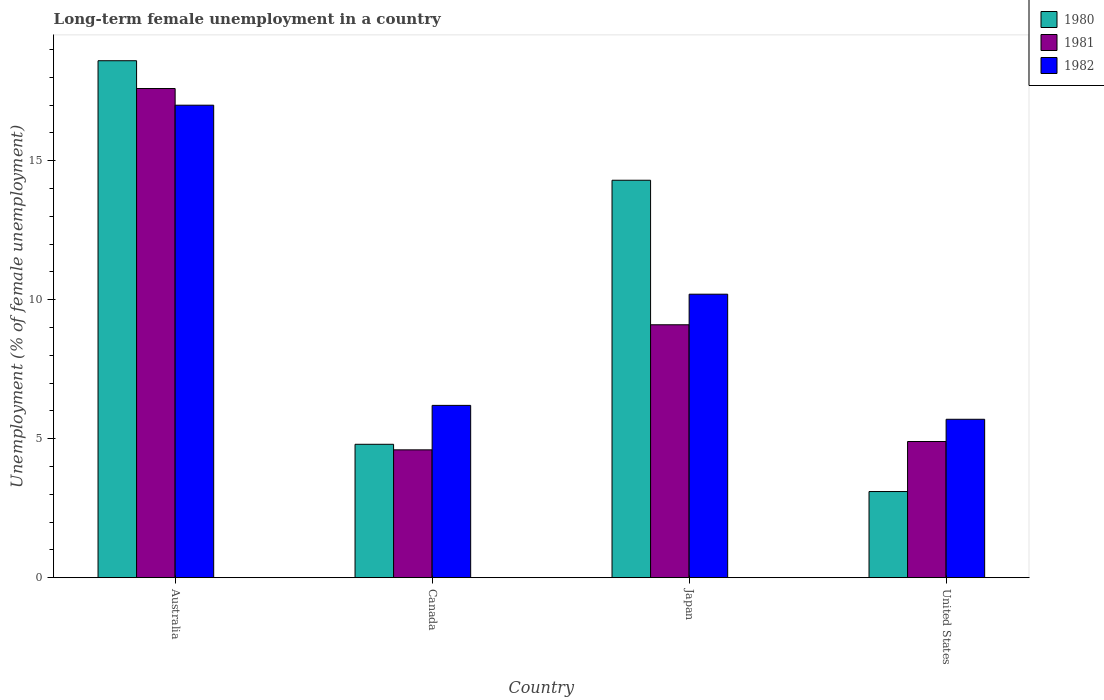Are the number of bars on each tick of the X-axis equal?
Give a very brief answer. Yes. What is the label of the 2nd group of bars from the left?
Your answer should be compact. Canada. What is the percentage of long-term unemployed female population in 1982 in Japan?
Your answer should be compact. 10.2. Across all countries, what is the maximum percentage of long-term unemployed female population in 1981?
Keep it short and to the point. 17.6. Across all countries, what is the minimum percentage of long-term unemployed female population in 1980?
Keep it short and to the point. 3.1. In which country was the percentage of long-term unemployed female population in 1981 minimum?
Keep it short and to the point. Canada. What is the total percentage of long-term unemployed female population in 1982 in the graph?
Your answer should be very brief. 39.1. What is the difference between the percentage of long-term unemployed female population in 1981 in Canada and that in United States?
Provide a short and direct response. -0.3. What is the difference between the percentage of long-term unemployed female population in 1982 in Canada and the percentage of long-term unemployed female population in 1980 in Australia?
Make the answer very short. -12.4. What is the average percentage of long-term unemployed female population in 1982 per country?
Keep it short and to the point. 9.77. What is the difference between the percentage of long-term unemployed female population of/in 1980 and percentage of long-term unemployed female population of/in 1982 in Japan?
Provide a short and direct response. 4.1. In how many countries, is the percentage of long-term unemployed female population in 1980 greater than 5 %?
Keep it short and to the point. 2. What is the ratio of the percentage of long-term unemployed female population in 1980 in Australia to that in Canada?
Your answer should be compact. 3.87. Is the difference between the percentage of long-term unemployed female population in 1980 in Canada and Japan greater than the difference between the percentage of long-term unemployed female population in 1982 in Canada and Japan?
Keep it short and to the point. No. What is the difference between the highest and the second highest percentage of long-term unemployed female population in 1982?
Your response must be concise. 6.8. What is the difference between the highest and the lowest percentage of long-term unemployed female population in 1980?
Your response must be concise. 15.5. In how many countries, is the percentage of long-term unemployed female population in 1981 greater than the average percentage of long-term unemployed female population in 1981 taken over all countries?
Keep it short and to the point. 2. What does the 1st bar from the right in Japan represents?
Give a very brief answer. 1982. How many bars are there?
Your response must be concise. 12. Are all the bars in the graph horizontal?
Provide a succinct answer. No. How many countries are there in the graph?
Give a very brief answer. 4. Are the values on the major ticks of Y-axis written in scientific E-notation?
Provide a succinct answer. No. Does the graph contain grids?
Your response must be concise. No. How many legend labels are there?
Your answer should be very brief. 3. How are the legend labels stacked?
Provide a succinct answer. Vertical. What is the title of the graph?
Give a very brief answer. Long-term female unemployment in a country. Does "1990" appear as one of the legend labels in the graph?
Ensure brevity in your answer.  No. What is the label or title of the X-axis?
Provide a short and direct response. Country. What is the label or title of the Y-axis?
Keep it short and to the point. Unemployment (% of female unemployment). What is the Unemployment (% of female unemployment) in 1980 in Australia?
Offer a terse response. 18.6. What is the Unemployment (% of female unemployment) of 1981 in Australia?
Your answer should be compact. 17.6. What is the Unemployment (% of female unemployment) in 1982 in Australia?
Provide a succinct answer. 17. What is the Unemployment (% of female unemployment) in 1980 in Canada?
Give a very brief answer. 4.8. What is the Unemployment (% of female unemployment) in 1981 in Canada?
Provide a succinct answer. 4.6. What is the Unemployment (% of female unemployment) in 1982 in Canada?
Offer a very short reply. 6.2. What is the Unemployment (% of female unemployment) in 1980 in Japan?
Make the answer very short. 14.3. What is the Unemployment (% of female unemployment) of 1981 in Japan?
Your response must be concise. 9.1. What is the Unemployment (% of female unemployment) in 1982 in Japan?
Offer a very short reply. 10.2. What is the Unemployment (% of female unemployment) in 1980 in United States?
Provide a succinct answer. 3.1. What is the Unemployment (% of female unemployment) in 1981 in United States?
Ensure brevity in your answer.  4.9. What is the Unemployment (% of female unemployment) in 1982 in United States?
Keep it short and to the point. 5.7. Across all countries, what is the maximum Unemployment (% of female unemployment) of 1980?
Offer a terse response. 18.6. Across all countries, what is the maximum Unemployment (% of female unemployment) of 1981?
Provide a succinct answer. 17.6. Across all countries, what is the minimum Unemployment (% of female unemployment) of 1980?
Ensure brevity in your answer.  3.1. Across all countries, what is the minimum Unemployment (% of female unemployment) of 1981?
Your response must be concise. 4.6. Across all countries, what is the minimum Unemployment (% of female unemployment) in 1982?
Your answer should be very brief. 5.7. What is the total Unemployment (% of female unemployment) in 1980 in the graph?
Your response must be concise. 40.8. What is the total Unemployment (% of female unemployment) of 1981 in the graph?
Provide a succinct answer. 36.2. What is the total Unemployment (% of female unemployment) in 1982 in the graph?
Ensure brevity in your answer.  39.1. What is the difference between the Unemployment (% of female unemployment) in 1982 in Australia and that in Canada?
Keep it short and to the point. 10.8. What is the difference between the Unemployment (% of female unemployment) of 1980 in Australia and that in Japan?
Your answer should be very brief. 4.3. What is the difference between the Unemployment (% of female unemployment) of 1980 in Australia and that in United States?
Your answer should be compact. 15.5. What is the difference between the Unemployment (% of female unemployment) in 1981 in Australia and that in United States?
Offer a terse response. 12.7. What is the difference between the Unemployment (% of female unemployment) in 1982 in Australia and that in United States?
Make the answer very short. 11.3. What is the difference between the Unemployment (% of female unemployment) of 1980 in Canada and that in Japan?
Your response must be concise. -9.5. What is the difference between the Unemployment (% of female unemployment) of 1982 in Canada and that in Japan?
Give a very brief answer. -4. What is the difference between the Unemployment (% of female unemployment) of 1980 in Canada and that in United States?
Keep it short and to the point. 1.7. What is the difference between the Unemployment (% of female unemployment) in 1982 in Canada and that in United States?
Keep it short and to the point. 0.5. What is the difference between the Unemployment (% of female unemployment) in 1980 in Japan and that in United States?
Keep it short and to the point. 11.2. What is the difference between the Unemployment (% of female unemployment) of 1981 in Japan and that in United States?
Your response must be concise. 4.2. What is the difference between the Unemployment (% of female unemployment) in 1980 in Australia and the Unemployment (% of female unemployment) in 1981 in Canada?
Give a very brief answer. 14. What is the difference between the Unemployment (% of female unemployment) in 1980 in Australia and the Unemployment (% of female unemployment) in 1981 in Japan?
Make the answer very short. 9.5. What is the difference between the Unemployment (% of female unemployment) in 1980 in Australia and the Unemployment (% of female unemployment) in 1982 in Japan?
Your response must be concise. 8.4. What is the difference between the Unemployment (% of female unemployment) in 1981 in Australia and the Unemployment (% of female unemployment) in 1982 in Japan?
Offer a very short reply. 7.4. What is the difference between the Unemployment (% of female unemployment) in 1981 in Australia and the Unemployment (% of female unemployment) in 1982 in United States?
Make the answer very short. 11.9. What is the difference between the Unemployment (% of female unemployment) in 1980 in Canada and the Unemployment (% of female unemployment) in 1982 in Japan?
Your answer should be very brief. -5.4. What is the difference between the Unemployment (% of female unemployment) of 1980 in Canada and the Unemployment (% of female unemployment) of 1981 in United States?
Give a very brief answer. -0.1. What is the difference between the Unemployment (% of female unemployment) in 1980 in Canada and the Unemployment (% of female unemployment) in 1982 in United States?
Keep it short and to the point. -0.9. What is the difference between the Unemployment (% of female unemployment) of 1980 in Japan and the Unemployment (% of female unemployment) of 1982 in United States?
Provide a short and direct response. 8.6. What is the difference between the Unemployment (% of female unemployment) of 1981 in Japan and the Unemployment (% of female unemployment) of 1982 in United States?
Your answer should be very brief. 3.4. What is the average Unemployment (% of female unemployment) in 1981 per country?
Offer a terse response. 9.05. What is the average Unemployment (% of female unemployment) of 1982 per country?
Give a very brief answer. 9.78. What is the difference between the Unemployment (% of female unemployment) in 1980 and Unemployment (% of female unemployment) in 1982 in Australia?
Offer a terse response. 1.6. What is the difference between the Unemployment (% of female unemployment) in 1980 and Unemployment (% of female unemployment) in 1982 in Canada?
Your answer should be compact. -1.4. What is the difference between the Unemployment (% of female unemployment) in 1981 and Unemployment (% of female unemployment) in 1982 in Canada?
Offer a very short reply. -1.6. What is the difference between the Unemployment (% of female unemployment) of 1980 and Unemployment (% of female unemployment) of 1982 in United States?
Your response must be concise. -2.6. What is the difference between the Unemployment (% of female unemployment) in 1981 and Unemployment (% of female unemployment) in 1982 in United States?
Provide a short and direct response. -0.8. What is the ratio of the Unemployment (% of female unemployment) in 1980 in Australia to that in Canada?
Provide a succinct answer. 3.88. What is the ratio of the Unemployment (% of female unemployment) in 1981 in Australia to that in Canada?
Offer a very short reply. 3.83. What is the ratio of the Unemployment (% of female unemployment) in 1982 in Australia to that in Canada?
Give a very brief answer. 2.74. What is the ratio of the Unemployment (% of female unemployment) of 1980 in Australia to that in Japan?
Provide a succinct answer. 1.3. What is the ratio of the Unemployment (% of female unemployment) of 1981 in Australia to that in Japan?
Keep it short and to the point. 1.93. What is the ratio of the Unemployment (% of female unemployment) in 1982 in Australia to that in Japan?
Give a very brief answer. 1.67. What is the ratio of the Unemployment (% of female unemployment) in 1981 in Australia to that in United States?
Provide a short and direct response. 3.59. What is the ratio of the Unemployment (% of female unemployment) of 1982 in Australia to that in United States?
Offer a very short reply. 2.98. What is the ratio of the Unemployment (% of female unemployment) of 1980 in Canada to that in Japan?
Your response must be concise. 0.34. What is the ratio of the Unemployment (% of female unemployment) of 1981 in Canada to that in Japan?
Ensure brevity in your answer.  0.51. What is the ratio of the Unemployment (% of female unemployment) of 1982 in Canada to that in Japan?
Offer a terse response. 0.61. What is the ratio of the Unemployment (% of female unemployment) of 1980 in Canada to that in United States?
Offer a terse response. 1.55. What is the ratio of the Unemployment (% of female unemployment) of 1981 in Canada to that in United States?
Your response must be concise. 0.94. What is the ratio of the Unemployment (% of female unemployment) in 1982 in Canada to that in United States?
Provide a short and direct response. 1.09. What is the ratio of the Unemployment (% of female unemployment) of 1980 in Japan to that in United States?
Your answer should be compact. 4.61. What is the ratio of the Unemployment (% of female unemployment) in 1981 in Japan to that in United States?
Offer a very short reply. 1.86. What is the ratio of the Unemployment (% of female unemployment) in 1982 in Japan to that in United States?
Make the answer very short. 1.79. What is the difference between the highest and the second highest Unemployment (% of female unemployment) of 1980?
Provide a short and direct response. 4.3. What is the difference between the highest and the second highest Unemployment (% of female unemployment) in 1982?
Offer a terse response. 6.8. 